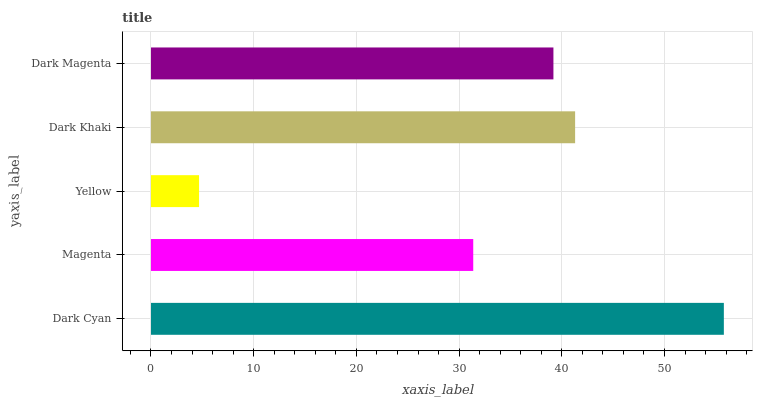Is Yellow the minimum?
Answer yes or no. Yes. Is Dark Cyan the maximum?
Answer yes or no. Yes. Is Magenta the minimum?
Answer yes or no. No. Is Magenta the maximum?
Answer yes or no. No. Is Dark Cyan greater than Magenta?
Answer yes or no. Yes. Is Magenta less than Dark Cyan?
Answer yes or no. Yes. Is Magenta greater than Dark Cyan?
Answer yes or no. No. Is Dark Cyan less than Magenta?
Answer yes or no. No. Is Dark Magenta the high median?
Answer yes or no. Yes. Is Dark Magenta the low median?
Answer yes or no. Yes. Is Dark Cyan the high median?
Answer yes or no. No. Is Magenta the low median?
Answer yes or no. No. 